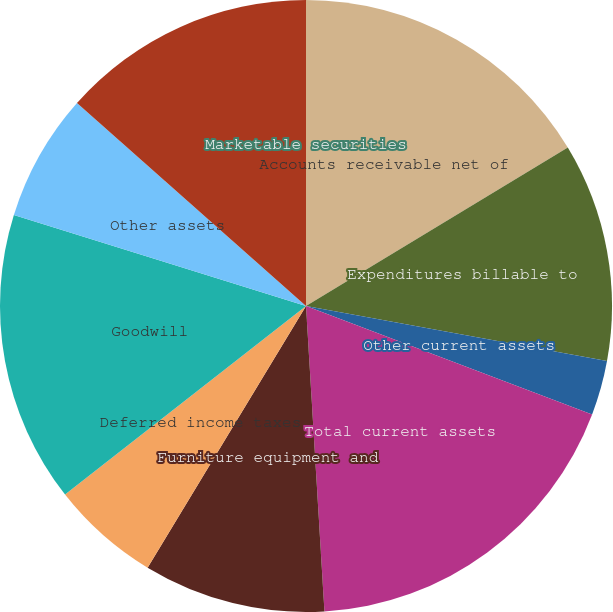Convert chart to OTSL. <chart><loc_0><loc_0><loc_500><loc_500><pie_chart><fcel>Marketable securities<fcel>Accounts receivable net of<fcel>Expenditures billable to<fcel>Other current assets<fcel>Total current assets<fcel>Furniture equipment and<fcel>Deferred income taxes<fcel>Goodwill<fcel>Other assets<fcel>Accrued liabilities<nl><fcel>0.0%<fcel>16.34%<fcel>11.54%<fcel>2.89%<fcel>18.27%<fcel>9.62%<fcel>5.77%<fcel>15.38%<fcel>6.73%<fcel>13.46%<nl></chart> 